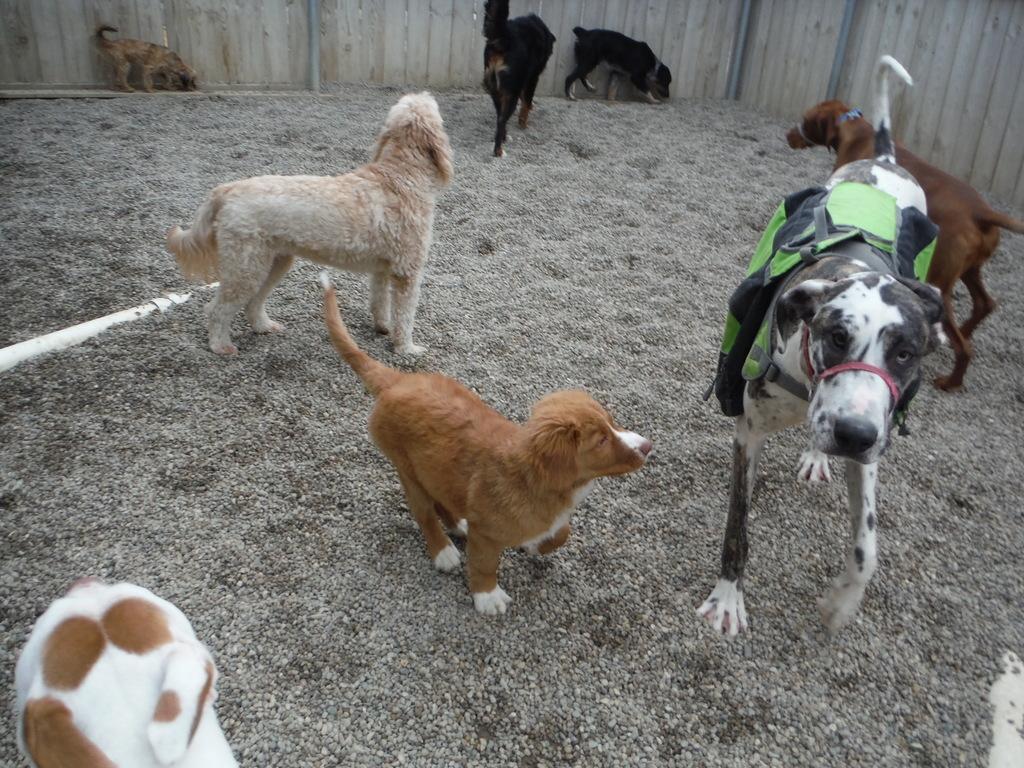Please provide a concise description of this image. In the image there are few dogs standing on the ground. On the ground there are small stones and also there is a white pipe. In the background there is a wooden wall. 